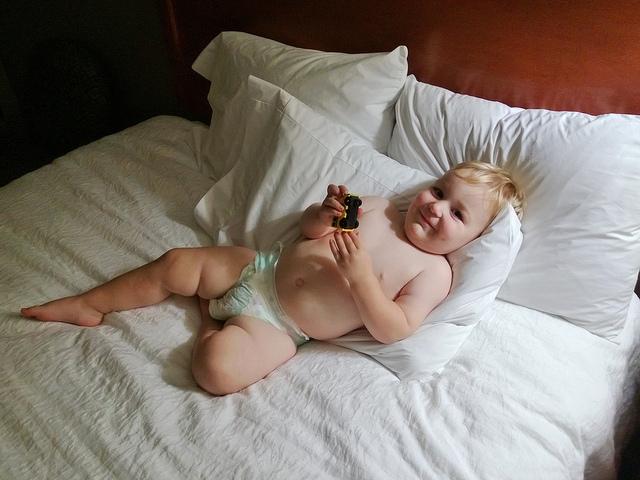Is the child eating?
Keep it brief. No. What is the child wearing?
Write a very short answer. Diaper. Is this a child's bed?
Concise answer only. No. What is the baby lying on?
Keep it brief. Bed. 